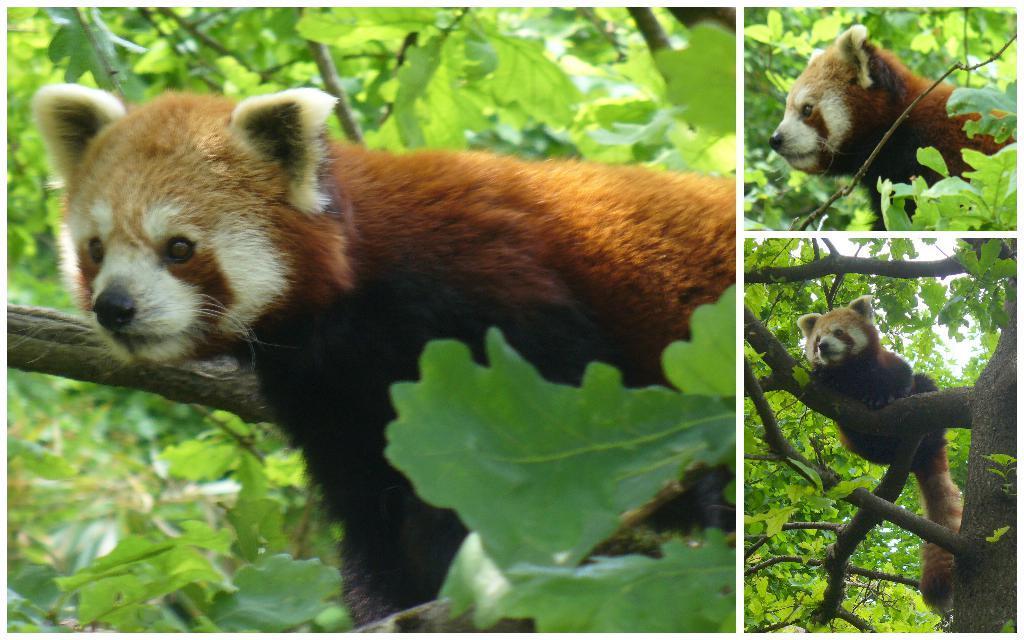How would you summarize this image in a sentence or two? This is a collage picture and in these three pictures we can see an animal on a tree branch and in the background we can see leaves. 